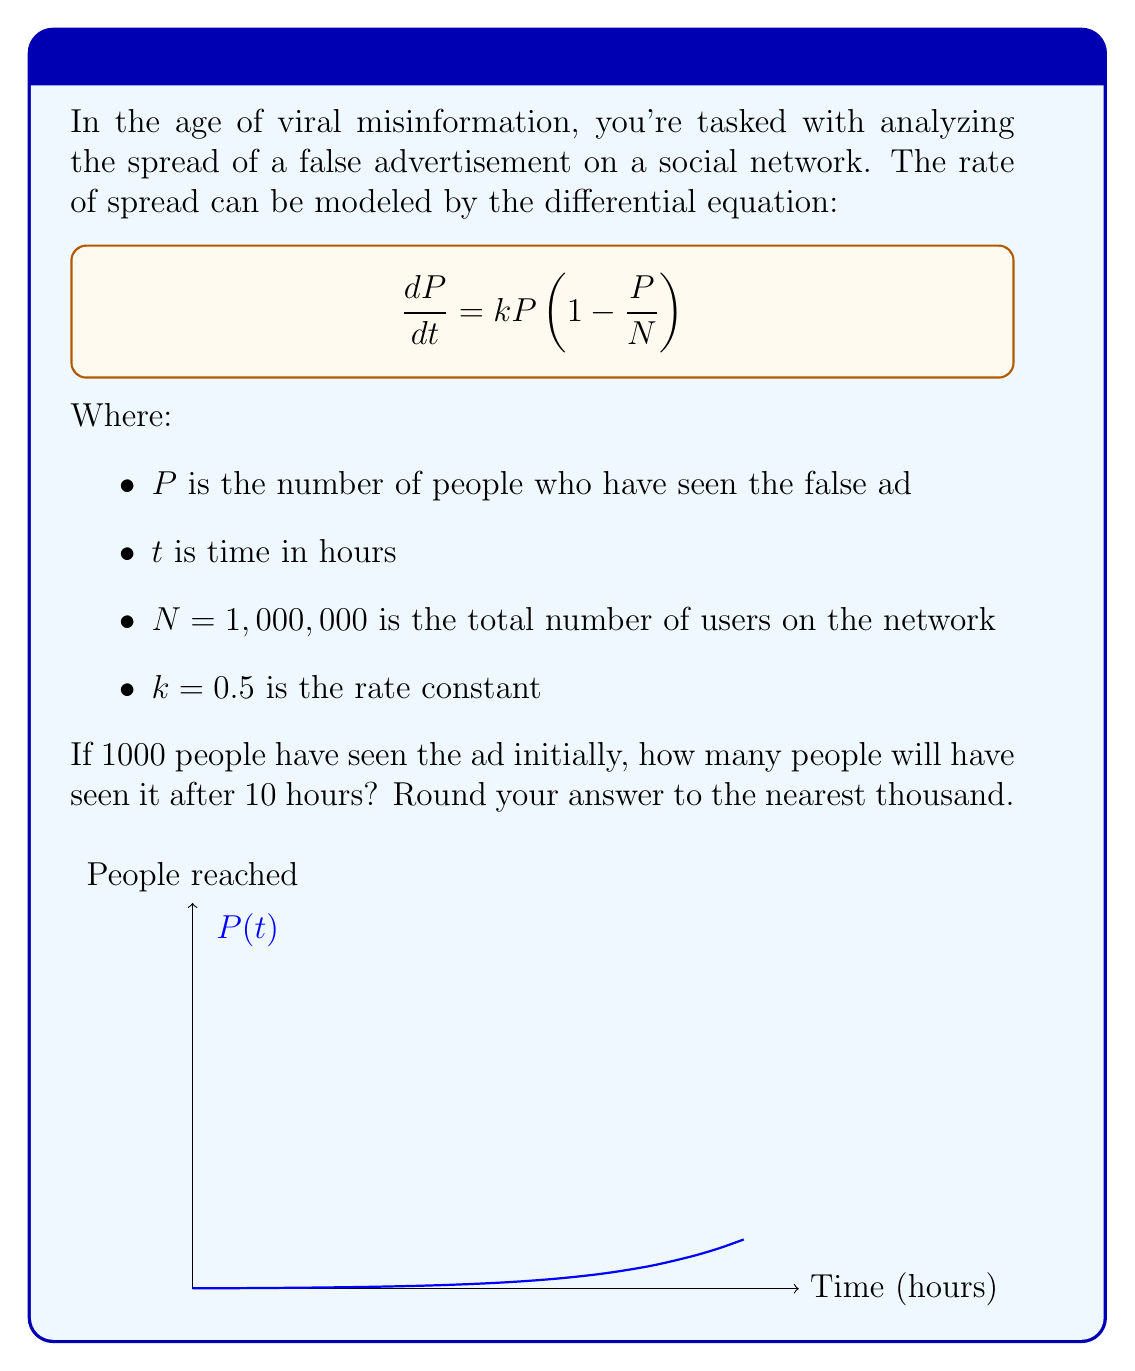Teach me how to tackle this problem. To solve this problem, we need to use the logistic growth model, which is described by the given differential equation. The solution to this equation is:

$$P(t) = \frac{N}{1 + (\frac{N}{P_0} - 1)e^{-kt}}$$

Where $P_0$ is the initial number of people who have seen the ad.

Let's plug in our values:
- $N = 1,000,000$
- $k = 0.5$
- $P_0 = 1,000$
- $t = 10$

$$P(10) = \frac{1,000,000}{1 + (\frac{1,000,000}{1,000} - 1)e^{-0.5 \cdot 10}}$$

$$= \frac{1,000,000}{1 + 999e^{-5}}$$

$$\approx \frac{1,000,000}{1 + 999 \cdot 0.00674}$$

$$\approx \frac{1,000,000}{7.73}$$

$$\approx 129,366$$

Rounding to the nearest thousand, we get 129,000.
Answer: 129,000 people 